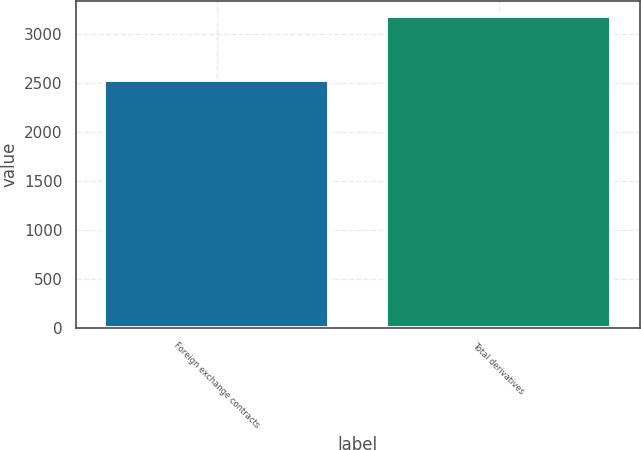<chart> <loc_0><loc_0><loc_500><loc_500><bar_chart><fcel>Foreign exchange contracts<fcel>Total derivatives<nl><fcel>2524<fcel>3177<nl></chart> 